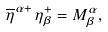<formula> <loc_0><loc_0><loc_500><loc_500>\overline { \eta } ^ { \alpha + } \, \eta ^ { + } _ { \beta } = M ^ { \alpha } _ { \beta } ,</formula> 